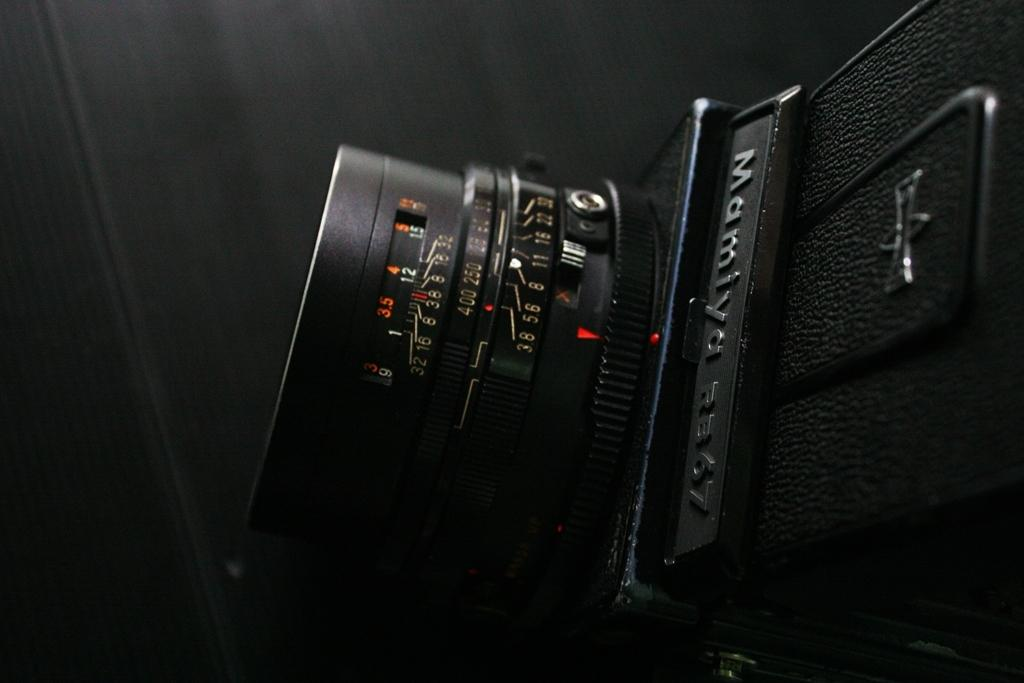What is the main subject of the image? The main subject of the image is a camera lens. Can you describe the camera lens in more detail? The image contains a zoomed-in picture of the camera lens. What type of giraffe can be seen grazing on the seashore in the image? There is no giraffe or seashore present in the image; it contains a zoomed-in picture of a camera lens. 